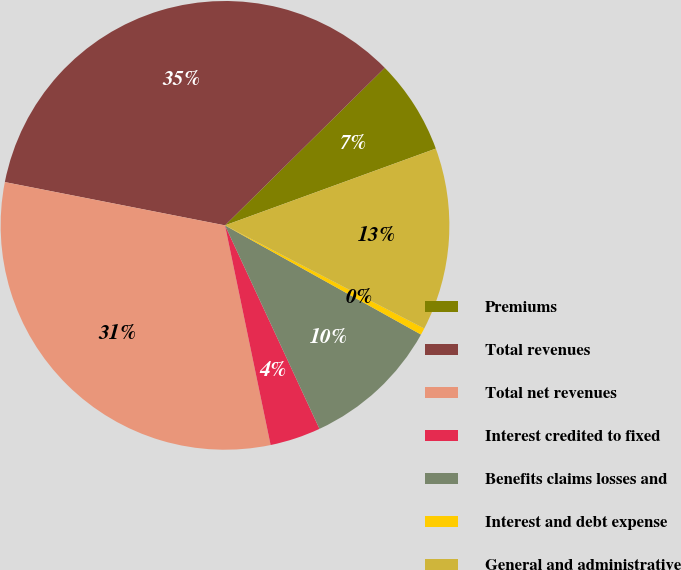<chart> <loc_0><loc_0><loc_500><loc_500><pie_chart><fcel>Premiums<fcel>Total revenues<fcel>Total net revenues<fcel>Interest credited to fixed<fcel>Benefits claims losses and<fcel>Interest and debt expense<fcel>General and administrative<nl><fcel>6.83%<fcel>34.52%<fcel>31.35%<fcel>3.66%<fcel>9.99%<fcel>0.49%<fcel>13.16%<nl></chart> 